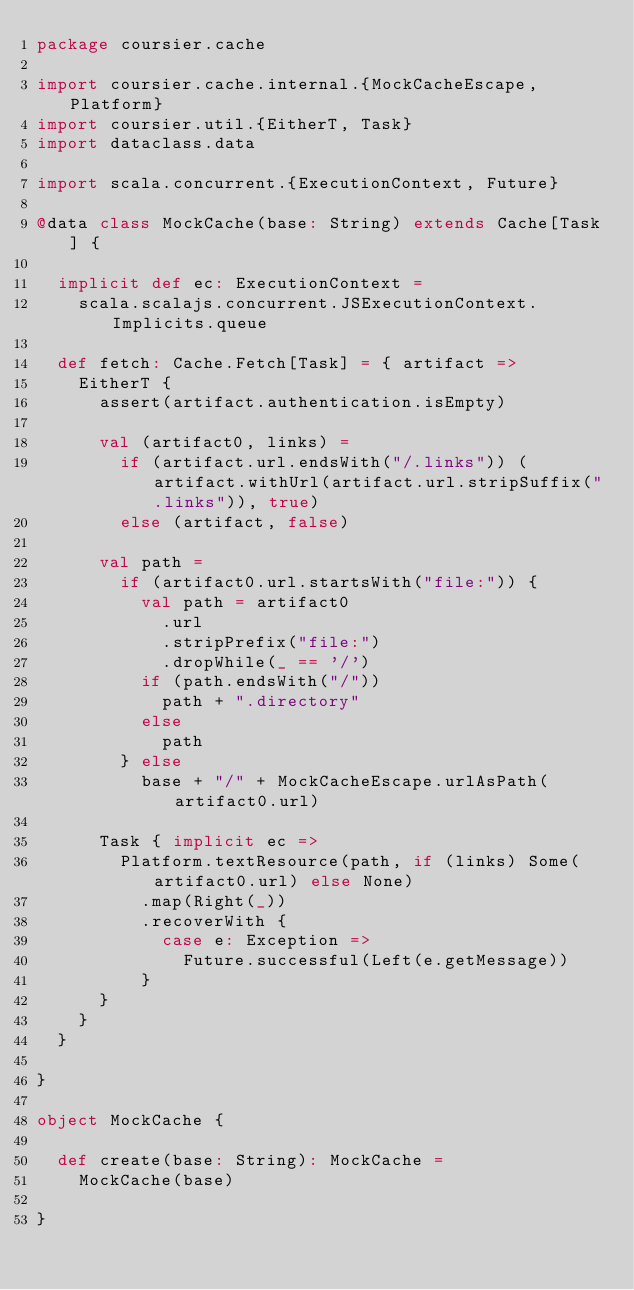Convert code to text. <code><loc_0><loc_0><loc_500><loc_500><_Scala_>package coursier.cache

import coursier.cache.internal.{MockCacheEscape, Platform}
import coursier.util.{EitherT, Task}
import dataclass.data

import scala.concurrent.{ExecutionContext, Future}

@data class MockCache(base: String) extends Cache[Task] {

  implicit def ec: ExecutionContext =
    scala.scalajs.concurrent.JSExecutionContext.Implicits.queue

  def fetch: Cache.Fetch[Task] = { artifact =>
    EitherT {
      assert(artifact.authentication.isEmpty)

      val (artifact0, links) =
        if (artifact.url.endsWith("/.links")) (artifact.withUrl(artifact.url.stripSuffix(".links")), true)
        else (artifact, false)

      val path =
        if (artifact0.url.startsWith("file:")) {
          val path = artifact0
            .url
            .stripPrefix("file:")
            .dropWhile(_ == '/')
          if (path.endsWith("/"))
            path + ".directory"
          else
            path
        } else
          base + "/" + MockCacheEscape.urlAsPath(artifact0.url)

      Task { implicit ec =>
        Platform.textResource(path, if (links) Some(artifact0.url) else None)
          .map(Right(_))
          .recoverWith {
            case e: Exception =>
              Future.successful(Left(e.getMessage))
          }
      }
    }
  }

}

object MockCache {

  def create(base: String): MockCache =
    MockCache(base)

}
</code> 